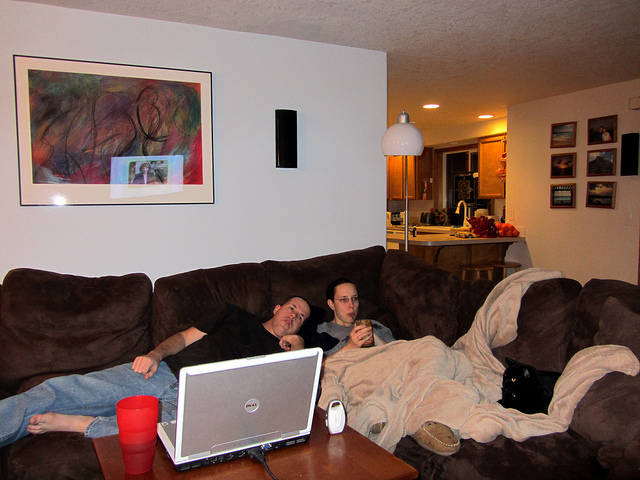Read and extract the text from this image. DELL 